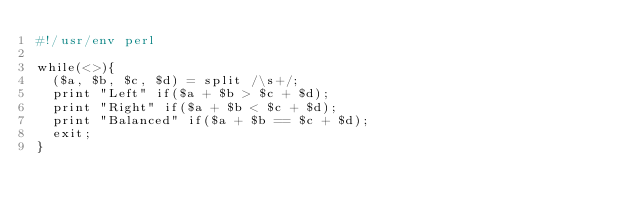Convert code to text. <code><loc_0><loc_0><loc_500><loc_500><_Perl_>#!/usr/env perl

while(<>){
  ($a, $b, $c, $d) = split /\s+/;
  print "Left" if($a + $b > $c + $d);
  print "Right" if($a + $b < $c + $d);
  print "Balanced" if($a + $b == $c + $d);
  exit;
}
</code> 